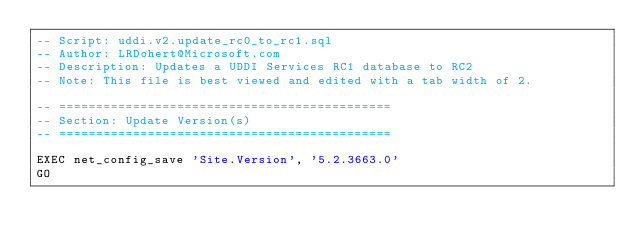<code> <loc_0><loc_0><loc_500><loc_500><_SQL_>-- Script: uddi.v2.update_rc0_to_rc1.sql
-- Author: LRDohert@Microsoft.com
-- Description: Updates a UDDI Services RC1 database to RC2
-- Note: This file is best viewed and edited with a tab width of 2.

-- =============================================
-- Section: Update Version(s)
-- =============================================

EXEC net_config_save 'Site.Version', '5.2.3663.0'
GO</code> 